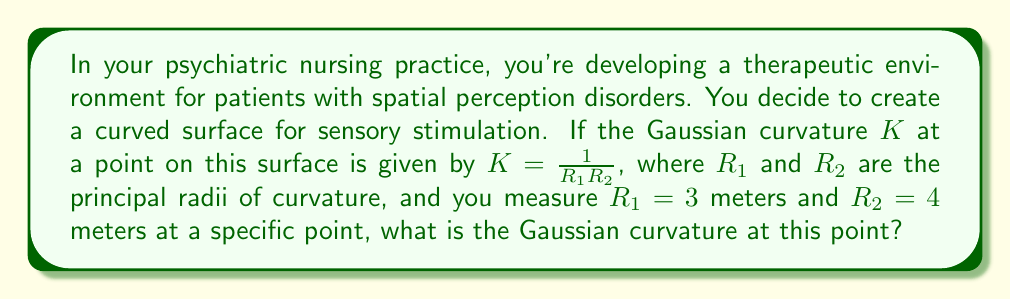Can you answer this question? Let's approach this step-by-step:

1) We are given the formula for Gaussian curvature:
   $$K = \frac{1}{R_1R_2}$$

2) We are also given the values:
   $R_1 = 3$ meters
   $R_2 = 4$ meters

3) To find the Gaussian curvature, we simply need to substitute these values into the formula:
   $$K = \frac{1}{(3)(4)}$$

4) Simplify:
   $$K = \frac{1}{12}$$

5) This can be expressed as a decimal:
   $$K = 0.0833...$$

6) In the context of non-Euclidean geometry, a positive Gaussian curvature indicates that the surface is locally spherical or ellipsoidal at this point. This means the surface curves in the same direction for both principal curvatures, like the surface of a ball.
Answer: $\frac{1}{12}$ m$^{-2}$ or approximately 0.0833 m$^{-2}$ 